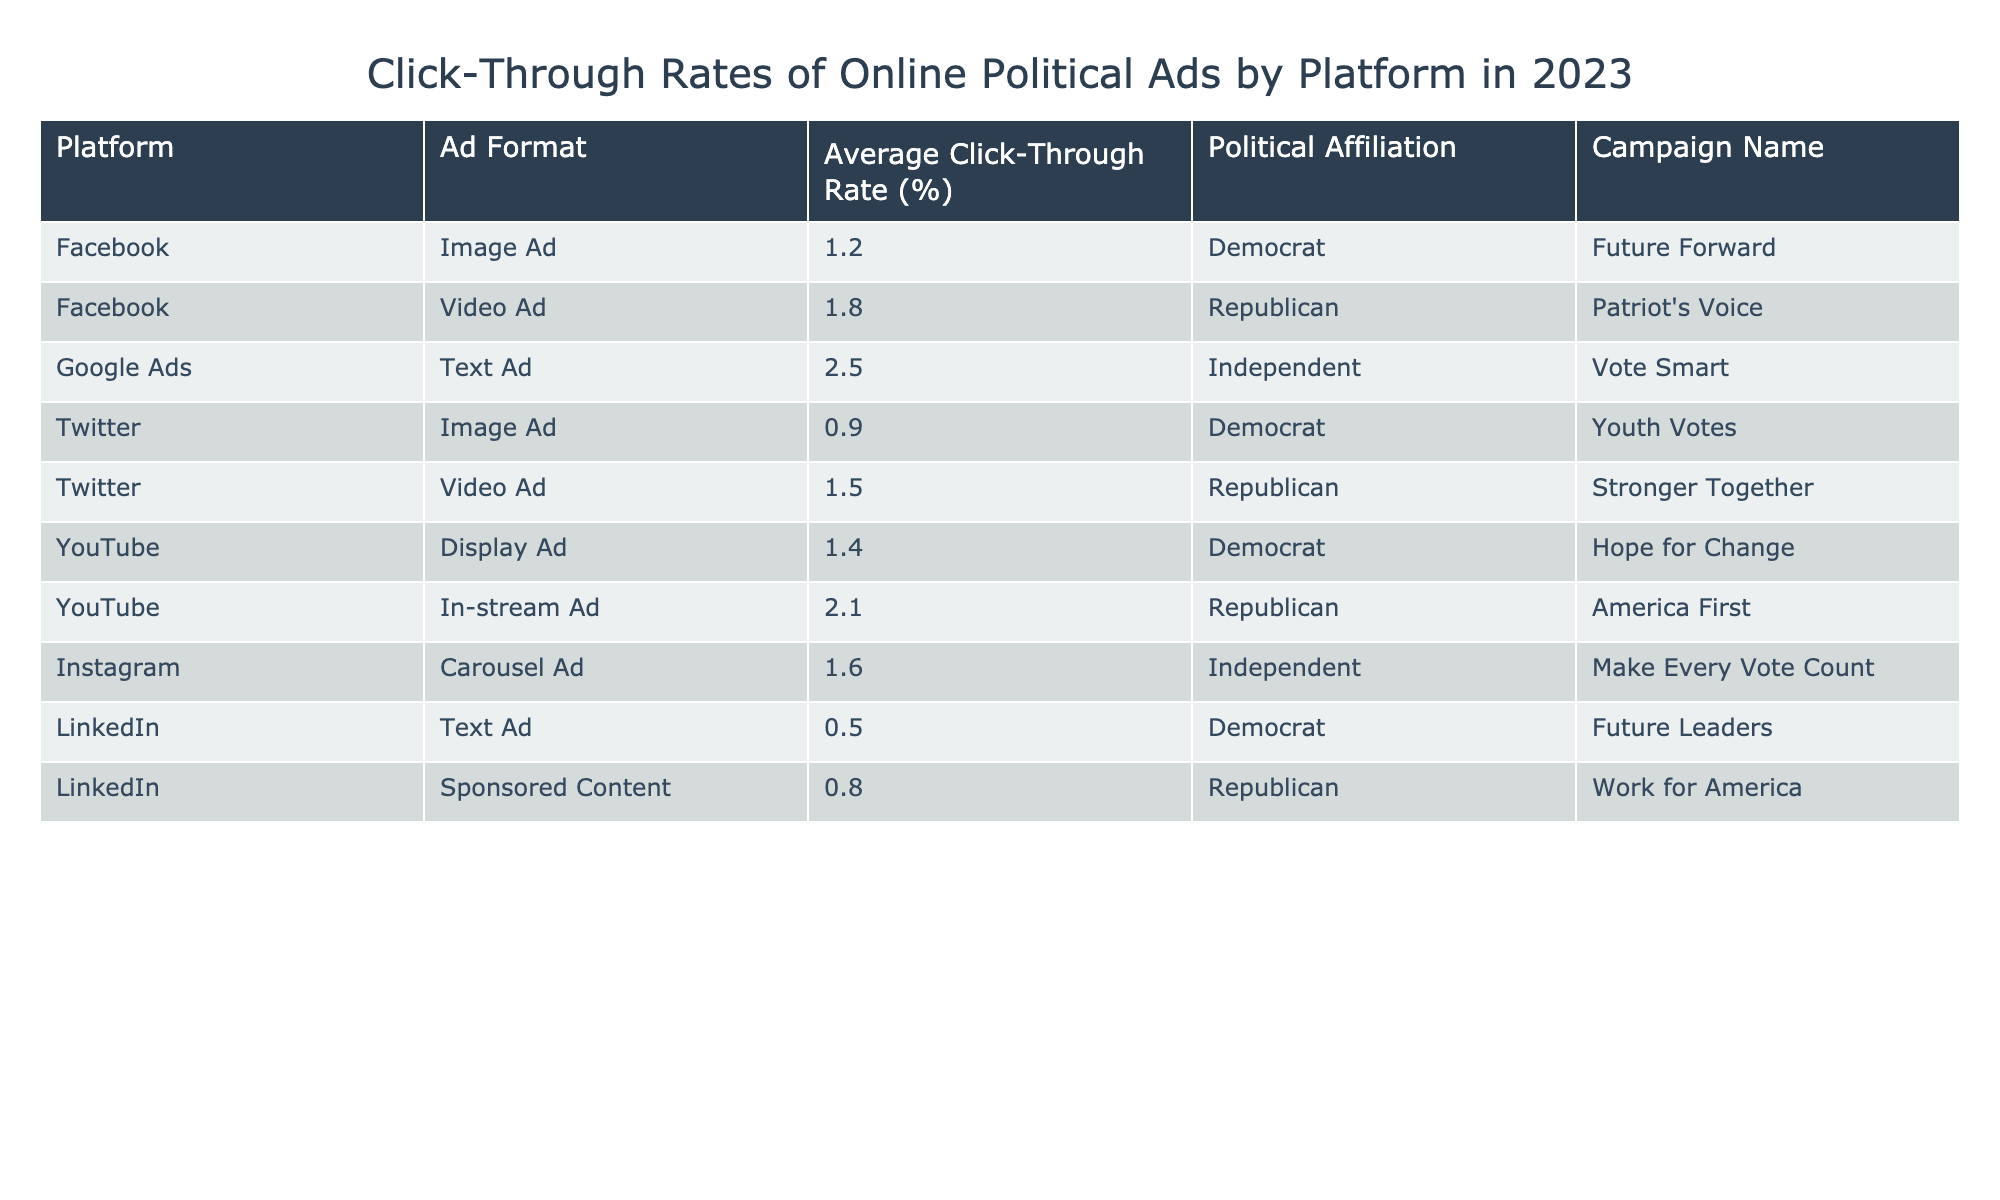What is the highest click-through rate among the ads listed? The click-through rate for YouTube's In-stream Ad is 2.1%, which is the highest compared to the other entries in the table.
Answer: 2.1% Which platform has the lowest average click-through rate? The lowest average click-through rate is found on LinkedIn's Text Ad at 0.5%.
Answer: 0.5% What is the average click-through rate for Democrat-affiliated ads? The Democrat-affiliated ads have click-through rates of 1.2%, 0.9%, and 1.4%. To find the average, sum these rates: 1.2 + 0.9 + 1.4 = 3.5%. There are 3 ads, so the average is 3.5/3 = 1.17%.
Answer: 1.17% Do all campaign names consist of at least two words? The campaign names are "Future Forward", "Patriot's Voice", "Vote Smart", "Youth Votes", "Stronger Together", "Hope for Change", "America First", "Make Every Vote Count", "Future Leaders", and "Work for America". Each of these names consists of at least two words.
Answer: Yes Which ad format has the highest click-through rate on Facebook? On Facebook, the Video Ad has a higher click-through rate of 1.8% compared to the Image Ad's 1.2%.
Answer: Video Ad What is the difference in click-through rates between the best-performing Republican ad and the best-performing Democrat ad? The best-performing Republican ad is YouTube's In-stream Ad at 2.1%, and the best-performing Democrat ad is Facebook's Video Ad at 1.8%. The difference is 2.1 - 1.8 = 0.3%.
Answer: 0.3% Are there more ads targeting Independent voters than those targeting Democrats? The table shows two ads for Independents ("Vote Smart" and "Make Every Vote Count") while there are three ads targeting Democrats ("Future Forward", "Youth Votes", and "Hope for Change"). Therefore, there are fewer ads for Independents compared to Democrats.
Answer: No Which platform has the highest average click-through rate across all ads listed? To find the average click-through rate per platform, we can calculate: Facebook (1.2 + 1.8)/2 = 1.5%, Google Ads (2.5), Twitter (0.9 + 1.5)/2 = 1.2%, YouTube (1.4 + 2.1)/2 = 1.75%, Instagram (1.6), LinkedIn (0.5 + 0.8)/2 = 0.65%. The highest average is therefore Google Ads at 2.5%.
Answer: Google Ads What is the click-through rate of the Instagram ad? The Instagram ad, specifically the Carousel Ad, has a click-through rate of 1.6%.
Answer: 1.6% 